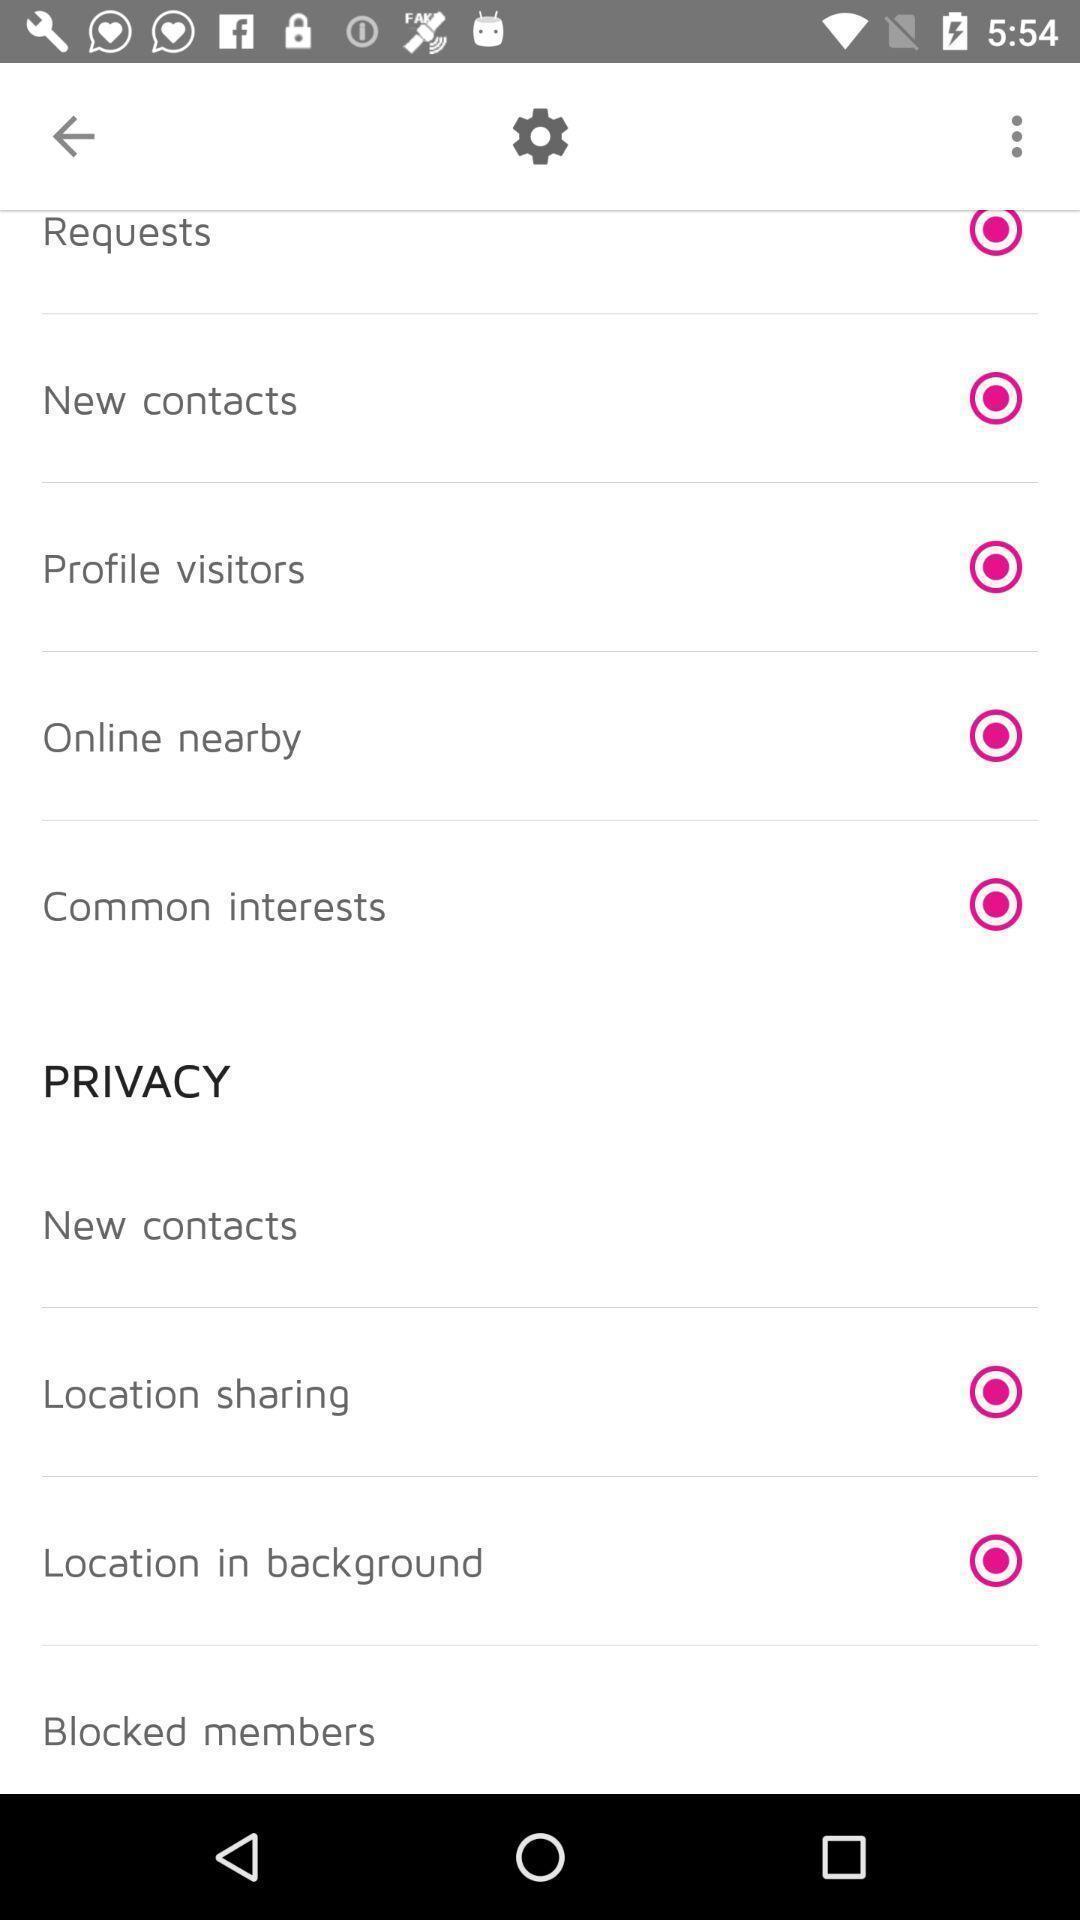Summarize the main components in this picture. Setting page displaying the various options. 